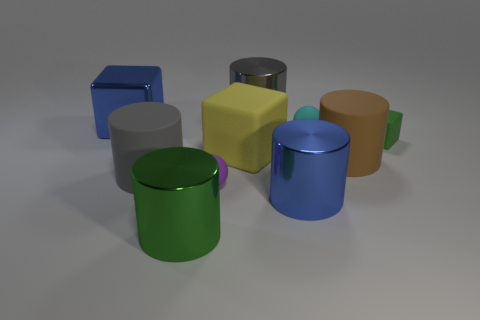Subtract all purple spheres. How many gray cylinders are left? 2 Subtract all gray cylinders. How many cylinders are left? 3 Subtract all brown cylinders. How many cylinders are left? 4 Subtract all blocks. How many objects are left? 7 Subtract all purple cylinders. Subtract all cyan spheres. How many cylinders are left? 5 Subtract 0 red balls. How many objects are left? 10 Subtract all large green cylinders. Subtract all brown cylinders. How many objects are left? 8 Add 4 big gray shiny things. How many big gray shiny things are left? 5 Add 1 matte balls. How many matte balls exist? 3 